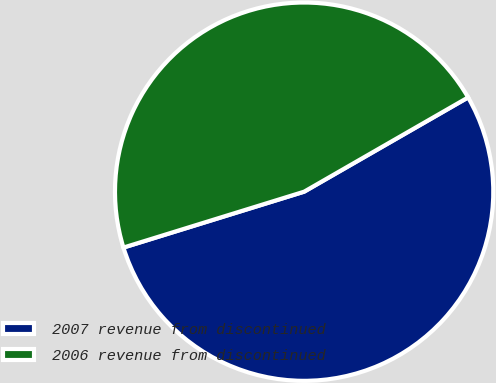Convert chart. <chart><loc_0><loc_0><loc_500><loc_500><pie_chart><fcel>2007 revenue from discontinued<fcel>2006 revenue from discontinued<nl><fcel>53.53%<fcel>46.47%<nl></chart> 